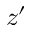Convert formula to latex. <formula><loc_0><loc_0><loc_500><loc_500>z ^ { \prime }</formula> 